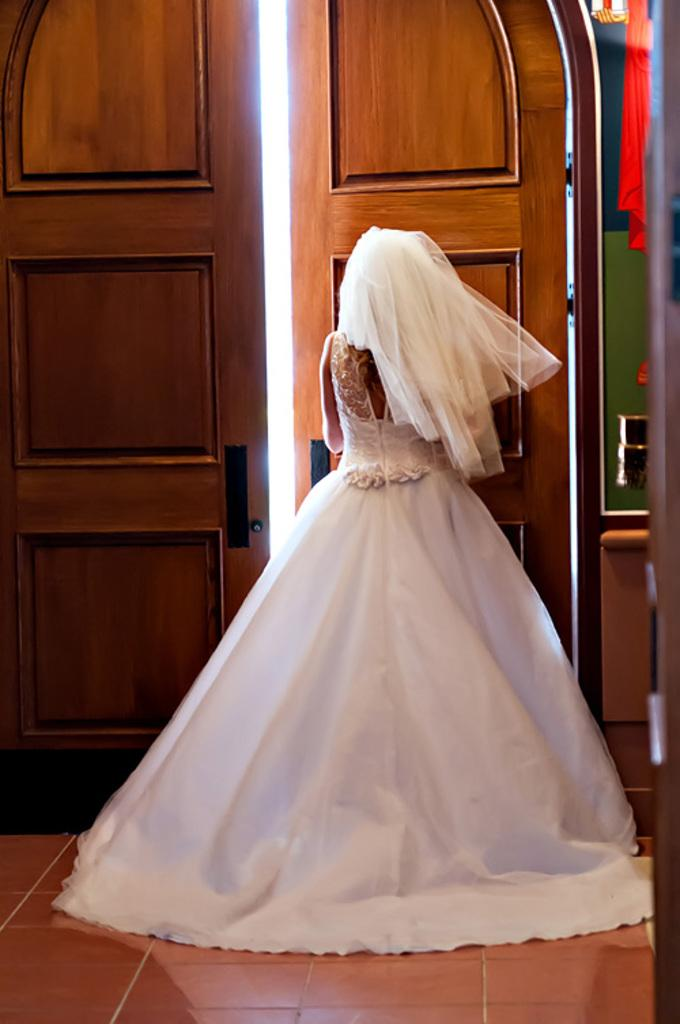Who is present in the image? There is a lady in the image. What is the lady doing in the image? The lady is standing at the door. What type of pleasure can be seen on the lady's face in the image? There is no indication of the lady's facial expression or any pleasure in the image. 